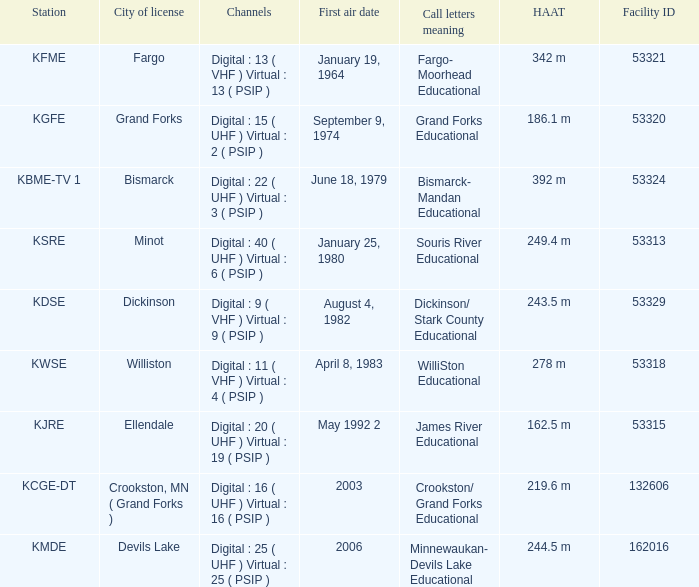What is the haat of devils lake 244.5 m. 